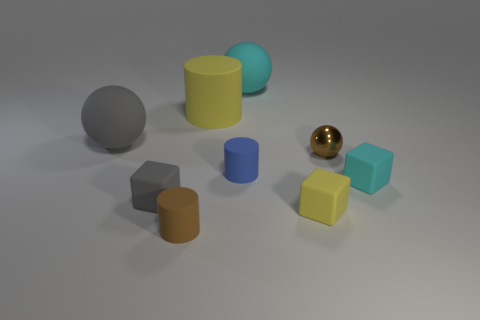Add 1 large gray spheres. How many objects exist? 10 Subtract all balls. How many objects are left? 6 Add 3 big yellow matte cylinders. How many big yellow matte cylinders exist? 4 Subtract 0 yellow spheres. How many objects are left? 9 Subtract all brown cylinders. Subtract all small cyan matte cubes. How many objects are left? 7 Add 7 tiny gray things. How many tiny gray things are left? 8 